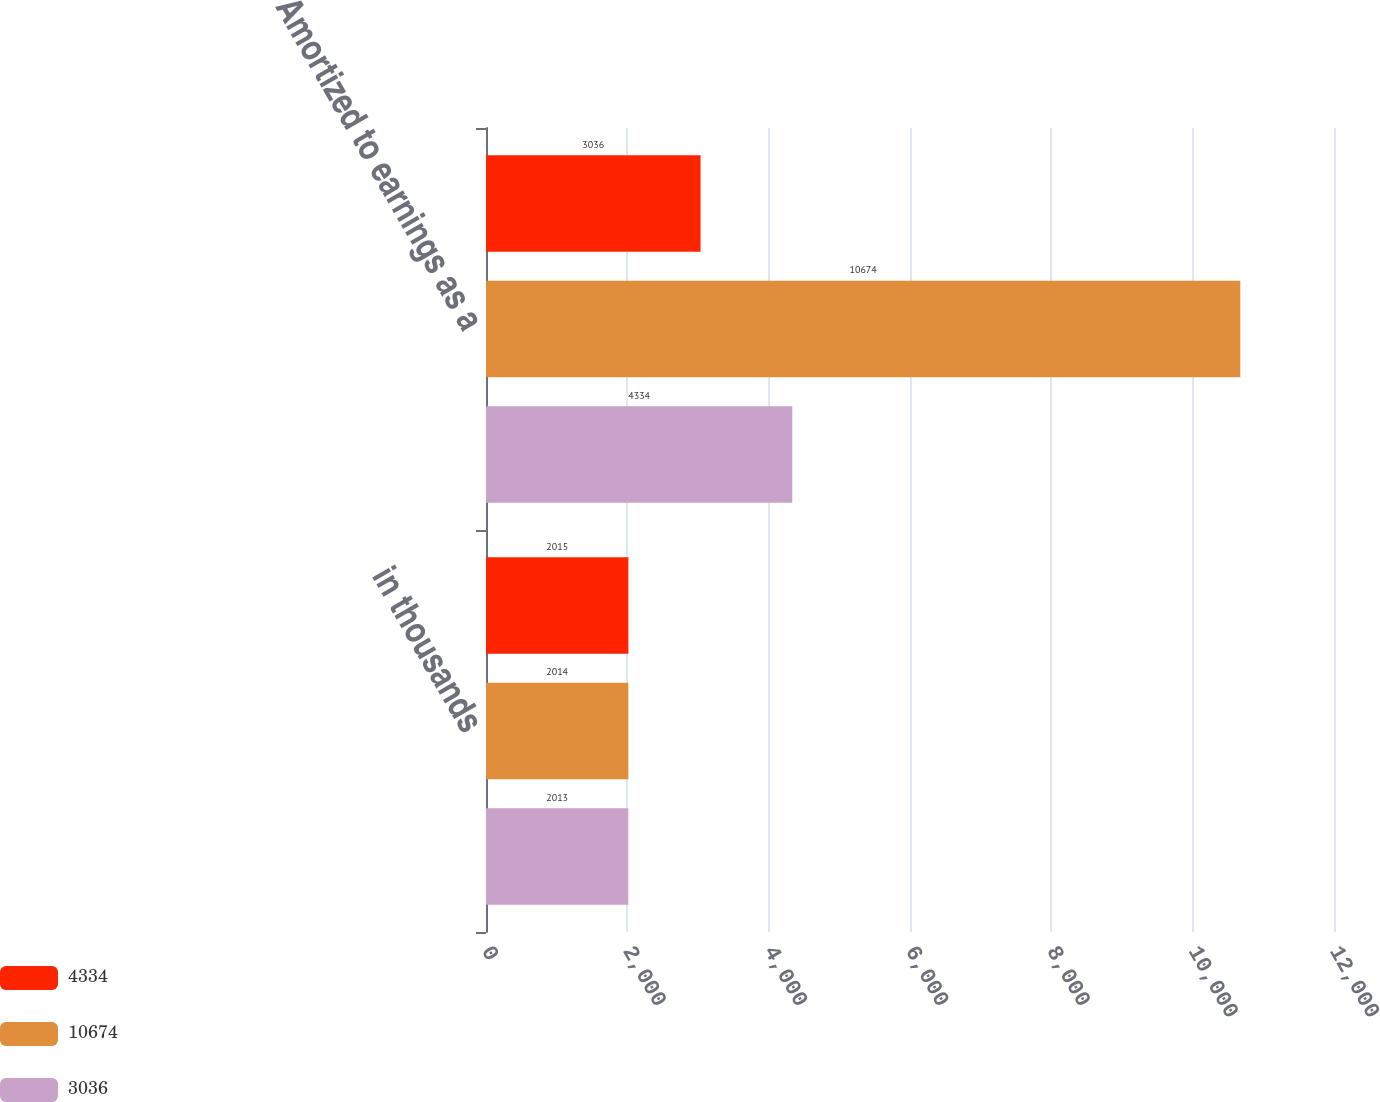Convert chart. <chart><loc_0><loc_0><loc_500><loc_500><stacked_bar_chart><ecel><fcel>in thousands<fcel>Amortized to earnings as a<nl><fcel>4334<fcel>2015<fcel>3036<nl><fcel>10674<fcel>2014<fcel>10674<nl><fcel>3036<fcel>2013<fcel>4334<nl></chart> 